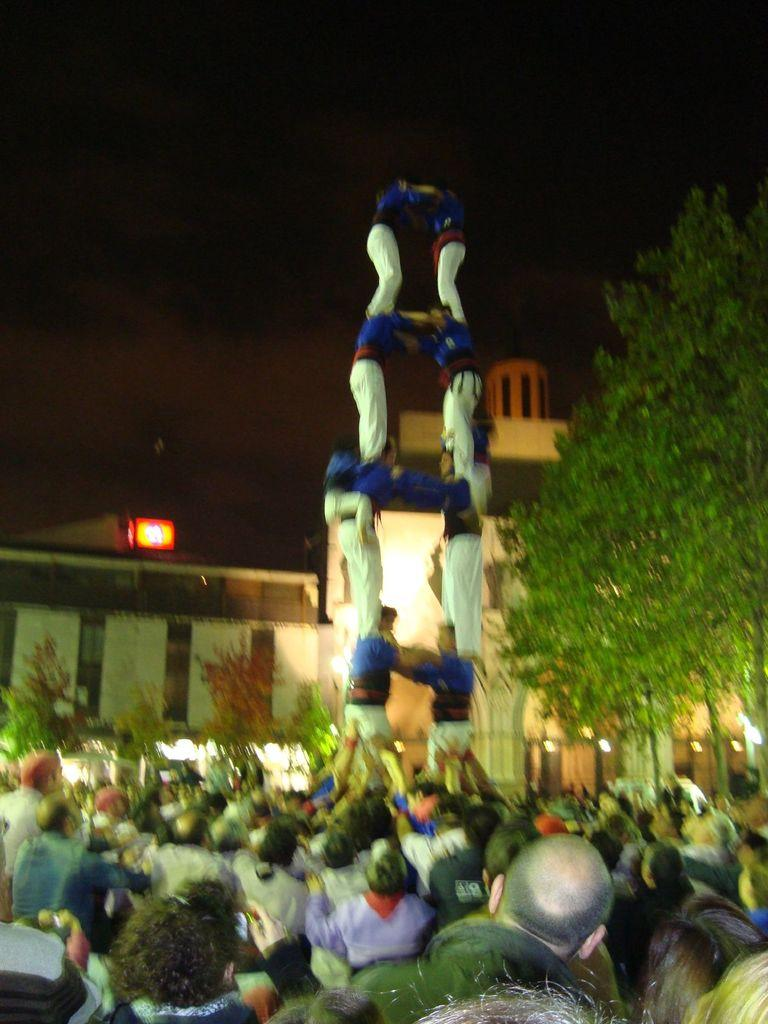What is the main subject of the image? The main subject of the image is a crowd. Can you describe the behavior of some people in the crowd? Some people in the crowd are standing on each other. What can be seen in the background of the image? There are trees and a building with walls and pillars in the background. What type of linen is being used to cover the fire in the image? There is no fire or linen present in the image. 